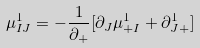<formula> <loc_0><loc_0><loc_500><loc_500>\mu ^ { 1 } _ { I J } = - \frac { 1 } { \partial _ { + } } [ \partial _ { J } \mu ^ { 1 } _ { + I } + \partial ^ { 1 } _ { J + } ]</formula> 